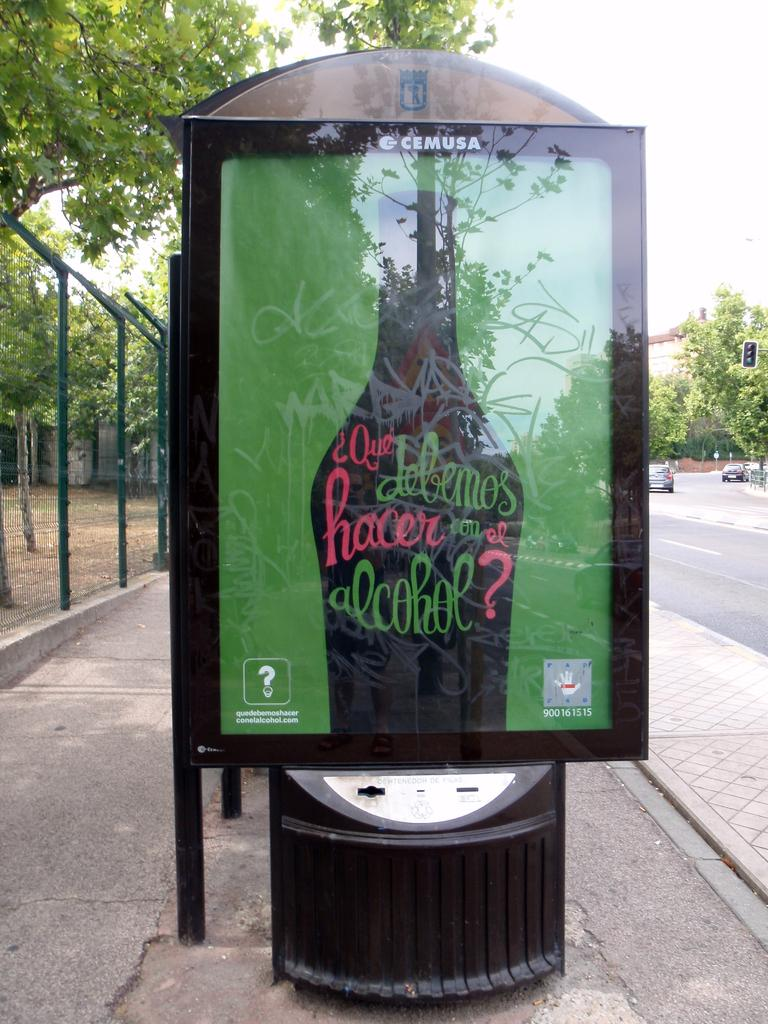<image>
Give a short and clear explanation of the subsequent image. A base stop has an ad that says Cemusa. 